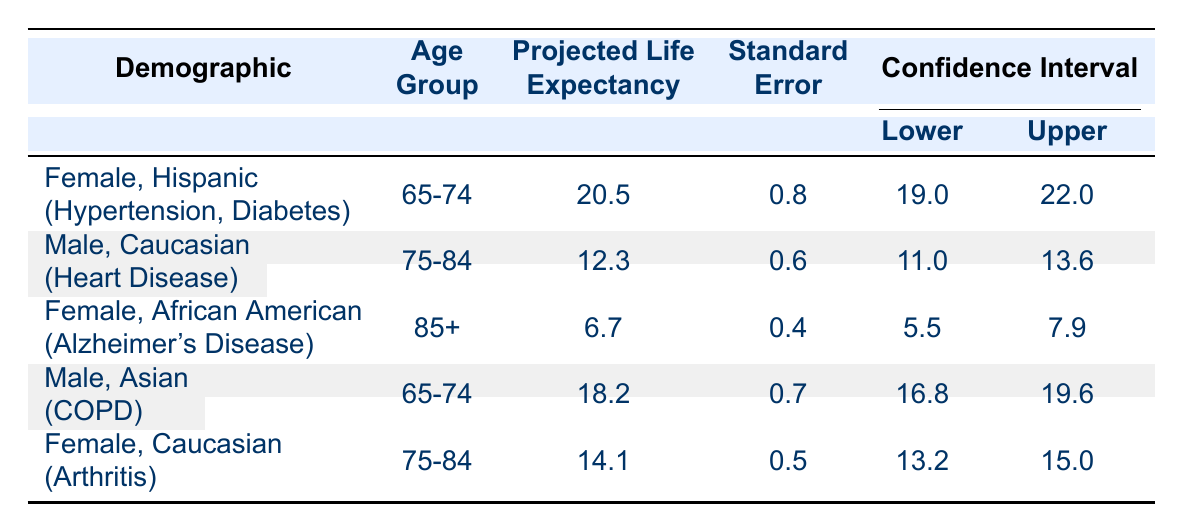What is the projected life expectancy for Hispanic females aged 65-74 with hypertension and diabetes? From the table, this demographic's projected life expectancy is listed as 20.5 years.
Answer: 20.5 For males aged 75-84 with heart disease, what is the upper limit of their confidence interval? The upper limit of the confidence interval for this demographic is provided as 13.6 in the table.
Answer: 13.6 Is the projected life expectancy greater for females aged 75-84 with arthritis compared to males aged 75-84 with heart disease? The projected life expectancy for females aged 75-84 with arthritis is 14.1, while for males aged 75-84 with heart disease, it is 12.3. Since 14.1 is greater than 12.3, the answer is yes.
Answer: Yes What is the difference in projected life expectancy between Asian males aged 65-74 with COPD and Hispanic females aged 65-74 with hypertension and diabetes? The projected life expectancy for Asian males is 18.2, and for Hispanic females, it is 20.5. The difference is calculated as 20.5 - 18.2 = 2.3 years.
Answer: 2.3 Considering confidence intervals, does the lower bound for projected life expectancy for females aged 85 and older with Alzheimer's disease overlap with the projected life expectancy for females aged 75-84 with arthritis? The lower bound for females aged 85 and older with Alzheimer's disease is 5.5, and for females aged 75-84 with arthritis, it's 13.2. Since 5.5 is less than 13.2, they do not overlap.
Answer: No What is the average projected life expectancy for the female demographics in the table? The projected life expectancies for females in the table are 20.5, 6.7, and 14.1. Their average is calculated as (20.5 + 6.7 + 14.1) / 3 = 13.8.
Answer: 13.8 Does living situation affect the projected life expectancy trend for females? From the female demographics listed, those living independently (20.5) and alone (14.1) have higher life expectancies compared to those in nursing homes (6.7). Thus, yes, it appears to affect the trend.
Answer: Yes What is the standard error associated with the projected life expectancy for males aged 65-74 with COPD? The standard error for this group, as provided in the table, is 0.7.
Answer: 0.7 